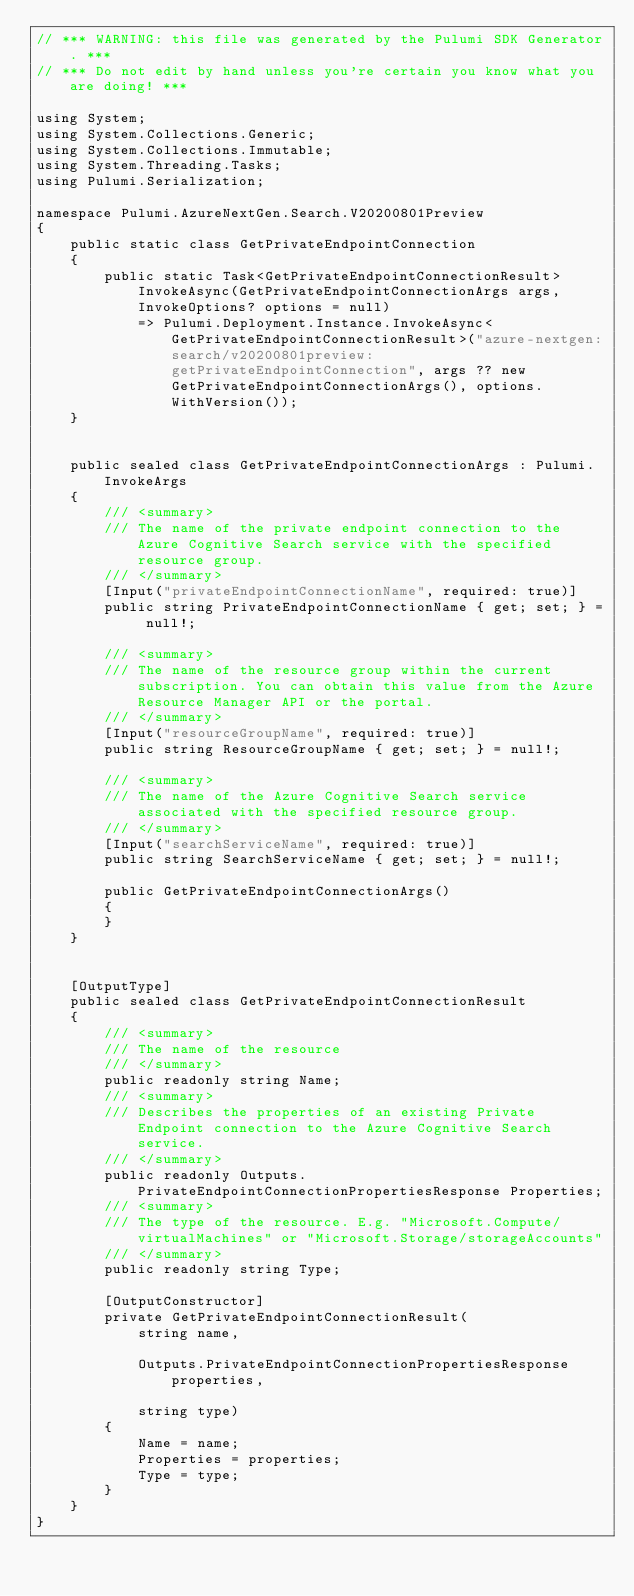Convert code to text. <code><loc_0><loc_0><loc_500><loc_500><_C#_>// *** WARNING: this file was generated by the Pulumi SDK Generator. ***
// *** Do not edit by hand unless you're certain you know what you are doing! ***

using System;
using System.Collections.Generic;
using System.Collections.Immutable;
using System.Threading.Tasks;
using Pulumi.Serialization;

namespace Pulumi.AzureNextGen.Search.V20200801Preview
{
    public static class GetPrivateEndpointConnection
    {
        public static Task<GetPrivateEndpointConnectionResult> InvokeAsync(GetPrivateEndpointConnectionArgs args, InvokeOptions? options = null)
            => Pulumi.Deployment.Instance.InvokeAsync<GetPrivateEndpointConnectionResult>("azure-nextgen:search/v20200801preview:getPrivateEndpointConnection", args ?? new GetPrivateEndpointConnectionArgs(), options.WithVersion());
    }


    public sealed class GetPrivateEndpointConnectionArgs : Pulumi.InvokeArgs
    {
        /// <summary>
        /// The name of the private endpoint connection to the Azure Cognitive Search service with the specified resource group.
        /// </summary>
        [Input("privateEndpointConnectionName", required: true)]
        public string PrivateEndpointConnectionName { get; set; } = null!;

        /// <summary>
        /// The name of the resource group within the current subscription. You can obtain this value from the Azure Resource Manager API or the portal.
        /// </summary>
        [Input("resourceGroupName", required: true)]
        public string ResourceGroupName { get; set; } = null!;

        /// <summary>
        /// The name of the Azure Cognitive Search service associated with the specified resource group.
        /// </summary>
        [Input("searchServiceName", required: true)]
        public string SearchServiceName { get; set; } = null!;

        public GetPrivateEndpointConnectionArgs()
        {
        }
    }


    [OutputType]
    public sealed class GetPrivateEndpointConnectionResult
    {
        /// <summary>
        /// The name of the resource
        /// </summary>
        public readonly string Name;
        /// <summary>
        /// Describes the properties of an existing Private Endpoint connection to the Azure Cognitive Search service.
        /// </summary>
        public readonly Outputs.PrivateEndpointConnectionPropertiesResponse Properties;
        /// <summary>
        /// The type of the resource. E.g. "Microsoft.Compute/virtualMachines" or "Microsoft.Storage/storageAccounts"
        /// </summary>
        public readonly string Type;

        [OutputConstructor]
        private GetPrivateEndpointConnectionResult(
            string name,

            Outputs.PrivateEndpointConnectionPropertiesResponse properties,

            string type)
        {
            Name = name;
            Properties = properties;
            Type = type;
        }
    }
}
</code> 